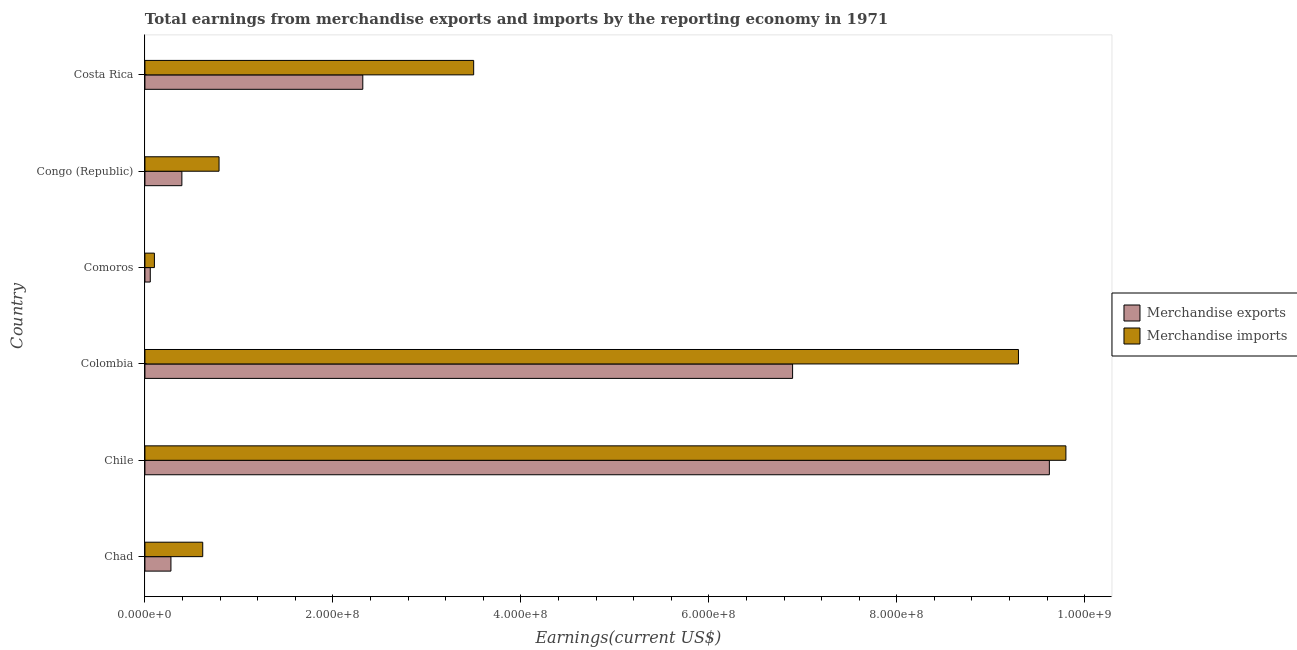How many different coloured bars are there?
Offer a very short reply. 2. Are the number of bars on each tick of the Y-axis equal?
Your response must be concise. Yes. How many bars are there on the 6th tick from the top?
Keep it short and to the point. 2. How many bars are there on the 4th tick from the bottom?
Provide a short and direct response. 2. What is the label of the 1st group of bars from the top?
Your response must be concise. Costa Rica. What is the earnings from merchandise imports in Costa Rica?
Your answer should be very brief. 3.50e+08. Across all countries, what is the maximum earnings from merchandise imports?
Offer a terse response. 9.80e+08. Across all countries, what is the minimum earnings from merchandise exports?
Your response must be concise. 5.70e+06. In which country was the earnings from merchandise imports maximum?
Offer a very short reply. Chile. In which country was the earnings from merchandise exports minimum?
Give a very brief answer. Comoros. What is the total earnings from merchandise exports in the graph?
Ensure brevity in your answer.  1.96e+09. What is the difference between the earnings from merchandise exports in Chad and that in Chile?
Your answer should be very brief. -9.35e+08. What is the difference between the earnings from merchandise imports in Costa Rica and the earnings from merchandise exports in Colombia?
Ensure brevity in your answer.  -3.39e+08. What is the average earnings from merchandise imports per country?
Your response must be concise. 4.02e+08. What is the difference between the earnings from merchandise exports and earnings from merchandise imports in Colombia?
Offer a very short reply. -2.40e+08. What is the ratio of the earnings from merchandise exports in Chad to that in Comoros?
Offer a terse response. 4.86. Is the difference between the earnings from merchandise exports in Congo (Republic) and Costa Rica greater than the difference between the earnings from merchandise imports in Congo (Republic) and Costa Rica?
Offer a very short reply. Yes. What is the difference between the highest and the second highest earnings from merchandise imports?
Your answer should be compact. 5.05e+07. What is the difference between the highest and the lowest earnings from merchandise imports?
Offer a terse response. 9.70e+08. In how many countries, is the earnings from merchandise imports greater than the average earnings from merchandise imports taken over all countries?
Provide a short and direct response. 2. What does the 1st bar from the top in Comoros represents?
Ensure brevity in your answer.  Merchandise imports. What does the 2nd bar from the bottom in Costa Rica represents?
Make the answer very short. Merchandise imports. How many bars are there?
Your answer should be compact. 12. Are all the bars in the graph horizontal?
Provide a short and direct response. Yes. How many countries are there in the graph?
Make the answer very short. 6. What is the difference between two consecutive major ticks on the X-axis?
Provide a succinct answer. 2.00e+08. Does the graph contain grids?
Provide a succinct answer. No. Where does the legend appear in the graph?
Provide a short and direct response. Center right. How many legend labels are there?
Provide a succinct answer. 2. What is the title of the graph?
Your answer should be compact. Total earnings from merchandise exports and imports by the reporting economy in 1971. Does "Female population" appear as one of the legend labels in the graph?
Give a very brief answer. No. What is the label or title of the X-axis?
Ensure brevity in your answer.  Earnings(current US$). What is the label or title of the Y-axis?
Provide a short and direct response. Country. What is the Earnings(current US$) of Merchandise exports in Chad?
Offer a very short reply. 2.77e+07. What is the Earnings(current US$) of Merchandise imports in Chad?
Ensure brevity in your answer.  6.15e+07. What is the Earnings(current US$) of Merchandise exports in Chile?
Keep it short and to the point. 9.62e+08. What is the Earnings(current US$) of Merchandise imports in Chile?
Offer a very short reply. 9.80e+08. What is the Earnings(current US$) in Merchandise exports in Colombia?
Give a very brief answer. 6.89e+08. What is the Earnings(current US$) in Merchandise imports in Colombia?
Offer a very short reply. 9.29e+08. What is the Earnings(current US$) of Merchandise exports in Comoros?
Your answer should be compact. 5.70e+06. What is the Earnings(current US$) in Merchandise imports in Comoros?
Provide a short and direct response. 1.01e+07. What is the Earnings(current US$) in Merchandise exports in Congo (Republic)?
Your response must be concise. 3.93e+07. What is the Earnings(current US$) of Merchandise imports in Congo (Republic)?
Provide a short and direct response. 7.89e+07. What is the Earnings(current US$) of Merchandise exports in Costa Rica?
Your response must be concise. 2.32e+08. What is the Earnings(current US$) of Merchandise imports in Costa Rica?
Keep it short and to the point. 3.50e+08. Across all countries, what is the maximum Earnings(current US$) in Merchandise exports?
Offer a terse response. 9.62e+08. Across all countries, what is the maximum Earnings(current US$) of Merchandise imports?
Ensure brevity in your answer.  9.80e+08. Across all countries, what is the minimum Earnings(current US$) of Merchandise exports?
Your answer should be very brief. 5.70e+06. Across all countries, what is the minimum Earnings(current US$) in Merchandise imports?
Your answer should be compact. 1.01e+07. What is the total Earnings(current US$) of Merchandise exports in the graph?
Provide a succinct answer. 1.96e+09. What is the total Earnings(current US$) in Merchandise imports in the graph?
Your answer should be compact. 2.41e+09. What is the difference between the Earnings(current US$) of Merchandise exports in Chad and that in Chile?
Give a very brief answer. -9.35e+08. What is the difference between the Earnings(current US$) in Merchandise imports in Chad and that in Chile?
Keep it short and to the point. -9.18e+08. What is the difference between the Earnings(current US$) in Merchandise exports in Chad and that in Colombia?
Provide a succinct answer. -6.61e+08. What is the difference between the Earnings(current US$) in Merchandise imports in Chad and that in Colombia?
Ensure brevity in your answer.  -8.68e+08. What is the difference between the Earnings(current US$) in Merchandise exports in Chad and that in Comoros?
Provide a succinct answer. 2.20e+07. What is the difference between the Earnings(current US$) in Merchandise imports in Chad and that in Comoros?
Provide a short and direct response. 5.14e+07. What is the difference between the Earnings(current US$) of Merchandise exports in Chad and that in Congo (Republic)?
Give a very brief answer. -1.16e+07. What is the difference between the Earnings(current US$) in Merchandise imports in Chad and that in Congo (Republic)?
Offer a very short reply. -1.74e+07. What is the difference between the Earnings(current US$) in Merchandise exports in Chad and that in Costa Rica?
Your response must be concise. -2.04e+08. What is the difference between the Earnings(current US$) in Merchandise imports in Chad and that in Costa Rica?
Make the answer very short. -2.88e+08. What is the difference between the Earnings(current US$) in Merchandise exports in Chile and that in Colombia?
Your answer should be very brief. 2.73e+08. What is the difference between the Earnings(current US$) in Merchandise imports in Chile and that in Colombia?
Offer a very short reply. 5.05e+07. What is the difference between the Earnings(current US$) in Merchandise exports in Chile and that in Comoros?
Make the answer very short. 9.57e+08. What is the difference between the Earnings(current US$) of Merchandise imports in Chile and that in Comoros?
Provide a short and direct response. 9.70e+08. What is the difference between the Earnings(current US$) of Merchandise exports in Chile and that in Congo (Republic)?
Make the answer very short. 9.23e+08. What is the difference between the Earnings(current US$) in Merchandise imports in Chile and that in Congo (Republic)?
Your answer should be very brief. 9.01e+08. What is the difference between the Earnings(current US$) of Merchandise exports in Chile and that in Costa Rica?
Your answer should be very brief. 7.31e+08. What is the difference between the Earnings(current US$) of Merchandise imports in Chile and that in Costa Rica?
Give a very brief answer. 6.30e+08. What is the difference between the Earnings(current US$) in Merchandise exports in Colombia and that in Comoros?
Ensure brevity in your answer.  6.83e+08. What is the difference between the Earnings(current US$) in Merchandise imports in Colombia and that in Comoros?
Offer a terse response. 9.19e+08. What is the difference between the Earnings(current US$) in Merchandise exports in Colombia and that in Congo (Republic)?
Provide a succinct answer. 6.50e+08. What is the difference between the Earnings(current US$) in Merchandise imports in Colombia and that in Congo (Republic)?
Provide a short and direct response. 8.51e+08. What is the difference between the Earnings(current US$) of Merchandise exports in Colombia and that in Costa Rica?
Your response must be concise. 4.57e+08. What is the difference between the Earnings(current US$) of Merchandise imports in Colombia and that in Costa Rica?
Give a very brief answer. 5.80e+08. What is the difference between the Earnings(current US$) in Merchandise exports in Comoros and that in Congo (Republic)?
Your answer should be compact. -3.36e+07. What is the difference between the Earnings(current US$) in Merchandise imports in Comoros and that in Congo (Republic)?
Provide a short and direct response. -6.88e+07. What is the difference between the Earnings(current US$) in Merchandise exports in Comoros and that in Costa Rica?
Ensure brevity in your answer.  -2.26e+08. What is the difference between the Earnings(current US$) in Merchandise imports in Comoros and that in Costa Rica?
Your answer should be compact. -3.40e+08. What is the difference between the Earnings(current US$) in Merchandise exports in Congo (Republic) and that in Costa Rica?
Offer a terse response. -1.93e+08. What is the difference between the Earnings(current US$) of Merchandise imports in Congo (Republic) and that in Costa Rica?
Keep it short and to the point. -2.71e+08. What is the difference between the Earnings(current US$) of Merchandise exports in Chad and the Earnings(current US$) of Merchandise imports in Chile?
Your answer should be very brief. -9.52e+08. What is the difference between the Earnings(current US$) of Merchandise exports in Chad and the Earnings(current US$) of Merchandise imports in Colombia?
Provide a short and direct response. -9.02e+08. What is the difference between the Earnings(current US$) in Merchandise exports in Chad and the Earnings(current US$) in Merchandise imports in Comoros?
Give a very brief answer. 1.76e+07. What is the difference between the Earnings(current US$) of Merchandise exports in Chad and the Earnings(current US$) of Merchandise imports in Congo (Republic)?
Offer a very short reply. -5.12e+07. What is the difference between the Earnings(current US$) in Merchandise exports in Chad and the Earnings(current US$) in Merchandise imports in Costa Rica?
Make the answer very short. -3.22e+08. What is the difference between the Earnings(current US$) of Merchandise exports in Chile and the Earnings(current US$) of Merchandise imports in Colombia?
Offer a terse response. 3.29e+07. What is the difference between the Earnings(current US$) of Merchandise exports in Chile and the Earnings(current US$) of Merchandise imports in Comoros?
Give a very brief answer. 9.52e+08. What is the difference between the Earnings(current US$) in Merchandise exports in Chile and the Earnings(current US$) in Merchandise imports in Congo (Republic)?
Make the answer very short. 8.83e+08. What is the difference between the Earnings(current US$) in Merchandise exports in Chile and the Earnings(current US$) in Merchandise imports in Costa Rica?
Ensure brevity in your answer.  6.13e+08. What is the difference between the Earnings(current US$) of Merchandise exports in Colombia and the Earnings(current US$) of Merchandise imports in Comoros?
Offer a terse response. 6.79e+08. What is the difference between the Earnings(current US$) in Merchandise exports in Colombia and the Earnings(current US$) in Merchandise imports in Congo (Republic)?
Keep it short and to the point. 6.10e+08. What is the difference between the Earnings(current US$) of Merchandise exports in Colombia and the Earnings(current US$) of Merchandise imports in Costa Rica?
Offer a terse response. 3.39e+08. What is the difference between the Earnings(current US$) of Merchandise exports in Comoros and the Earnings(current US$) of Merchandise imports in Congo (Republic)?
Give a very brief answer. -7.32e+07. What is the difference between the Earnings(current US$) of Merchandise exports in Comoros and the Earnings(current US$) of Merchandise imports in Costa Rica?
Offer a very short reply. -3.44e+08. What is the difference between the Earnings(current US$) of Merchandise exports in Congo (Republic) and the Earnings(current US$) of Merchandise imports in Costa Rica?
Ensure brevity in your answer.  -3.10e+08. What is the average Earnings(current US$) of Merchandise exports per country?
Provide a short and direct response. 3.26e+08. What is the average Earnings(current US$) of Merchandise imports per country?
Give a very brief answer. 4.02e+08. What is the difference between the Earnings(current US$) of Merchandise exports and Earnings(current US$) of Merchandise imports in Chad?
Your answer should be very brief. -3.38e+07. What is the difference between the Earnings(current US$) of Merchandise exports and Earnings(current US$) of Merchandise imports in Chile?
Your response must be concise. -1.76e+07. What is the difference between the Earnings(current US$) of Merchandise exports and Earnings(current US$) of Merchandise imports in Colombia?
Offer a terse response. -2.40e+08. What is the difference between the Earnings(current US$) in Merchandise exports and Earnings(current US$) in Merchandise imports in Comoros?
Give a very brief answer. -4.40e+06. What is the difference between the Earnings(current US$) of Merchandise exports and Earnings(current US$) of Merchandise imports in Congo (Republic)?
Your answer should be very brief. -3.96e+07. What is the difference between the Earnings(current US$) of Merchandise exports and Earnings(current US$) of Merchandise imports in Costa Rica?
Your answer should be compact. -1.18e+08. What is the ratio of the Earnings(current US$) in Merchandise exports in Chad to that in Chile?
Give a very brief answer. 0.03. What is the ratio of the Earnings(current US$) in Merchandise imports in Chad to that in Chile?
Provide a succinct answer. 0.06. What is the ratio of the Earnings(current US$) in Merchandise exports in Chad to that in Colombia?
Ensure brevity in your answer.  0.04. What is the ratio of the Earnings(current US$) of Merchandise imports in Chad to that in Colombia?
Provide a succinct answer. 0.07. What is the ratio of the Earnings(current US$) of Merchandise exports in Chad to that in Comoros?
Ensure brevity in your answer.  4.86. What is the ratio of the Earnings(current US$) in Merchandise imports in Chad to that in Comoros?
Keep it short and to the point. 6.09. What is the ratio of the Earnings(current US$) in Merchandise exports in Chad to that in Congo (Republic)?
Your response must be concise. 0.7. What is the ratio of the Earnings(current US$) of Merchandise imports in Chad to that in Congo (Republic)?
Your response must be concise. 0.78. What is the ratio of the Earnings(current US$) in Merchandise exports in Chad to that in Costa Rica?
Keep it short and to the point. 0.12. What is the ratio of the Earnings(current US$) of Merchandise imports in Chad to that in Costa Rica?
Provide a succinct answer. 0.18. What is the ratio of the Earnings(current US$) in Merchandise exports in Chile to that in Colombia?
Provide a short and direct response. 1.4. What is the ratio of the Earnings(current US$) in Merchandise imports in Chile to that in Colombia?
Your response must be concise. 1.05. What is the ratio of the Earnings(current US$) in Merchandise exports in Chile to that in Comoros?
Give a very brief answer. 168.83. What is the ratio of the Earnings(current US$) of Merchandise imports in Chile to that in Comoros?
Provide a succinct answer. 97.03. What is the ratio of the Earnings(current US$) in Merchandise exports in Chile to that in Congo (Republic)?
Provide a succinct answer. 24.48. What is the ratio of the Earnings(current US$) in Merchandise imports in Chile to that in Congo (Republic)?
Ensure brevity in your answer.  12.42. What is the ratio of the Earnings(current US$) in Merchandise exports in Chile to that in Costa Rica?
Give a very brief answer. 4.15. What is the ratio of the Earnings(current US$) of Merchandise imports in Chile to that in Costa Rica?
Provide a succinct answer. 2.8. What is the ratio of the Earnings(current US$) of Merchandise exports in Colombia to that in Comoros?
Your response must be concise. 120.9. What is the ratio of the Earnings(current US$) of Merchandise imports in Colombia to that in Comoros?
Make the answer very short. 92.03. What is the ratio of the Earnings(current US$) of Merchandise exports in Colombia to that in Congo (Republic)?
Give a very brief answer. 17.53. What is the ratio of the Earnings(current US$) in Merchandise imports in Colombia to that in Congo (Republic)?
Your answer should be compact. 11.78. What is the ratio of the Earnings(current US$) of Merchandise exports in Colombia to that in Costa Rica?
Offer a terse response. 2.97. What is the ratio of the Earnings(current US$) in Merchandise imports in Colombia to that in Costa Rica?
Offer a very short reply. 2.66. What is the ratio of the Earnings(current US$) of Merchandise exports in Comoros to that in Congo (Republic)?
Keep it short and to the point. 0.14. What is the ratio of the Earnings(current US$) of Merchandise imports in Comoros to that in Congo (Republic)?
Offer a very short reply. 0.13. What is the ratio of the Earnings(current US$) in Merchandise exports in Comoros to that in Costa Rica?
Your response must be concise. 0.02. What is the ratio of the Earnings(current US$) in Merchandise imports in Comoros to that in Costa Rica?
Your answer should be very brief. 0.03. What is the ratio of the Earnings(current US$) of Merchandise exports in Congo (Republic) to that in Costa Rica?
Ensure brevity in your answer.  0.17. What is the ratio of the Earnings(current US$) in Merchandise imports in Congo (Republic) to that in Costa Rica?
Give a very brief answer. 0.23. What is the difference between the highest and the second highest Earnings(current US$) of Merchandise exports?
Your answer should be compact. 2.73e+08. What is the difference between the highest and the second highest Earnings(current US$) of Merchandise imports?
Provide a short and direct response. 5.05e+07. What is the difference between the highest and the lowest Earnings(current US$) of Merchandise exports?
Ensure brevity in your answer.  9.57e+08. What is the difference between the highest and the lowest Earnings(current US$) of Merchandise imports?
Offer a very short reply. 9.70e+08. 